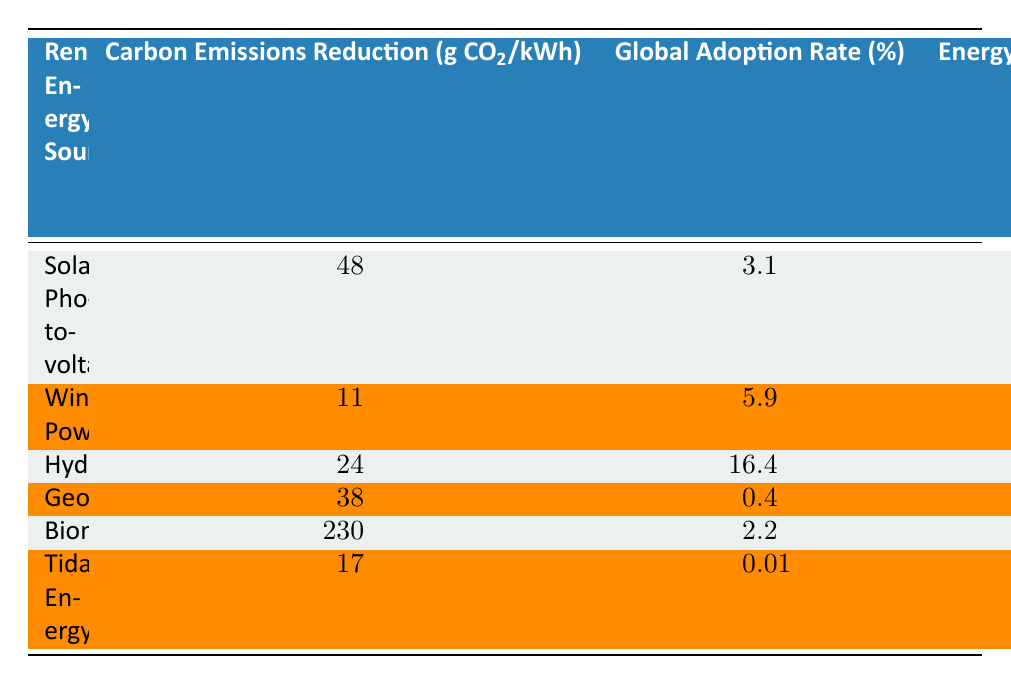What is the Carbon Emissions Reduction for Wind Power? The table indicates that Wind Power has a Carbon Emissions Reduction of 11 g CO2/kWh. I can find this value directly in the Wind Power row under the Carbon Emissions Reduction column.
Answer: 11 Which renewable energy source has the highest Energy Return on Investment (EROI)? Looking at the EROI values across all renewable energy sources, Hydroelectric stands out with an EROI of 84.0, which is greater than the values for Solar Photovoltaic, Wind Power, Geothermal, Biomass, and Tidal Energy. This information is found in the respective EROI column.
Answer: Hydroelectric Is Tidal Energy visually appealing for artwork? According to the table, Tidal Energy is labeled as "High" in the Visual Appeal for Artwork column, which indicates a positive answer to the question.
Answer: Yes What is the average Carbon Emissions Reduction of Solar Photovoltaic, Wind Power, and Geothermal? To find the average, I first sum the Carbon Emissions Reduction values for these three sources: (48 + 11 + 38) = 97. Then, I divide by the total number of sources (3), so 97 / 3 = 32.33.
Answer: 32.33 Which renewable energy source has the lowest Global Adoption Rate? By reviewing the Global Adoption Rate for each source, I find that Geothermal has the lowest rate at 0.4%, which is less than the rates for all other sources in the table.
Answer: Geothermal What is the difference in Carbon Emissions Reduction between Biomass and Solar Photovoltaic? Biomass has a Carbon Emissions Reduction of 230 g CO2/kWh, while Solar Photovoltaic has 48 g CO2/kWh. Calculating the difference gives: 230 - 48 = 182.
Answer: 182 Are there any renewable energy sources with a Global Adoption Rate over 10%? Based on the Global Adoption Rate column, only Hydroelectric has a rate of 16.4%, which is the only value exceeding 10%. The other sources have rates below this threshold.
Answer: Yes What is the total Land Use Efficiency of all renewable energy sources listed? By adding the Land Use Efficiency values: (120 + 36 + 1 + 500 + 2 + 180) = 839. This sum represents the combined efficiency across all sources.
Answer: 839 Does Wind Power have a higher Carbon Emissions Reduction than Geothermal? Wind Power's reduction is 11 g CO2/kWh and Geothermal's is 38 g CO2/kWh. Since 11 is less than 38, this statement is false.
Answer: No 